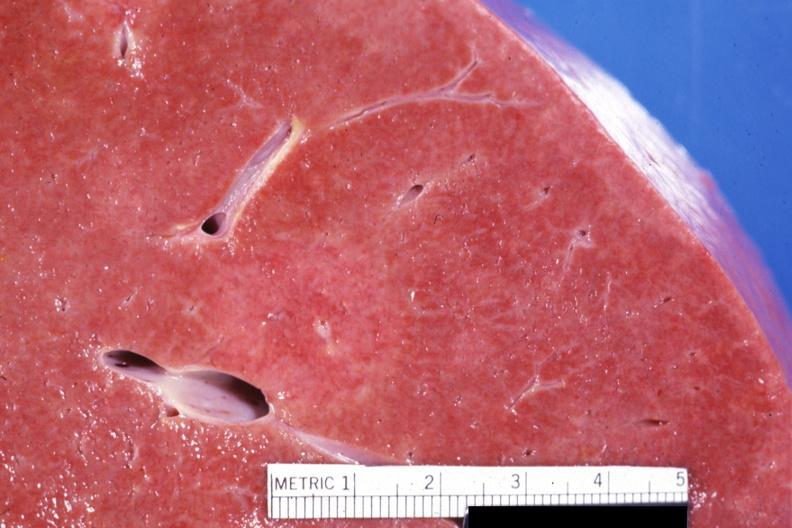re this close-up of cut surface infiltrates visible?
Answer the question using a single word or phrase. Yes 